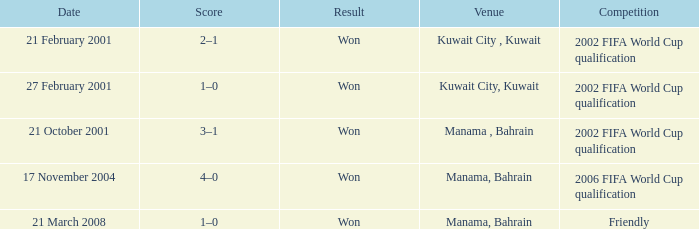On which date was the match in Manama, Bahrain? 21 October 2001, 17 November 2004, 21 March 2008. 